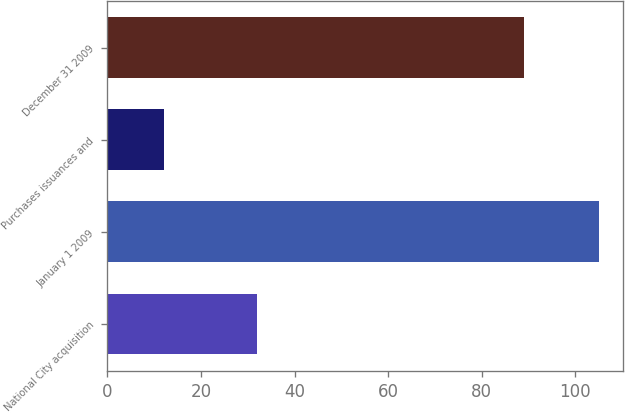<chart> <loc_0><loc_0><loc_500><loc_500><bar_chart><fcel>National City acquisition<fcel>January 1 2009<fcel>Purchases issuances and<fcel>December 31 2009<nl><fcel>32<fcel>105<fcel>12<fcel>89<nl></chart> 